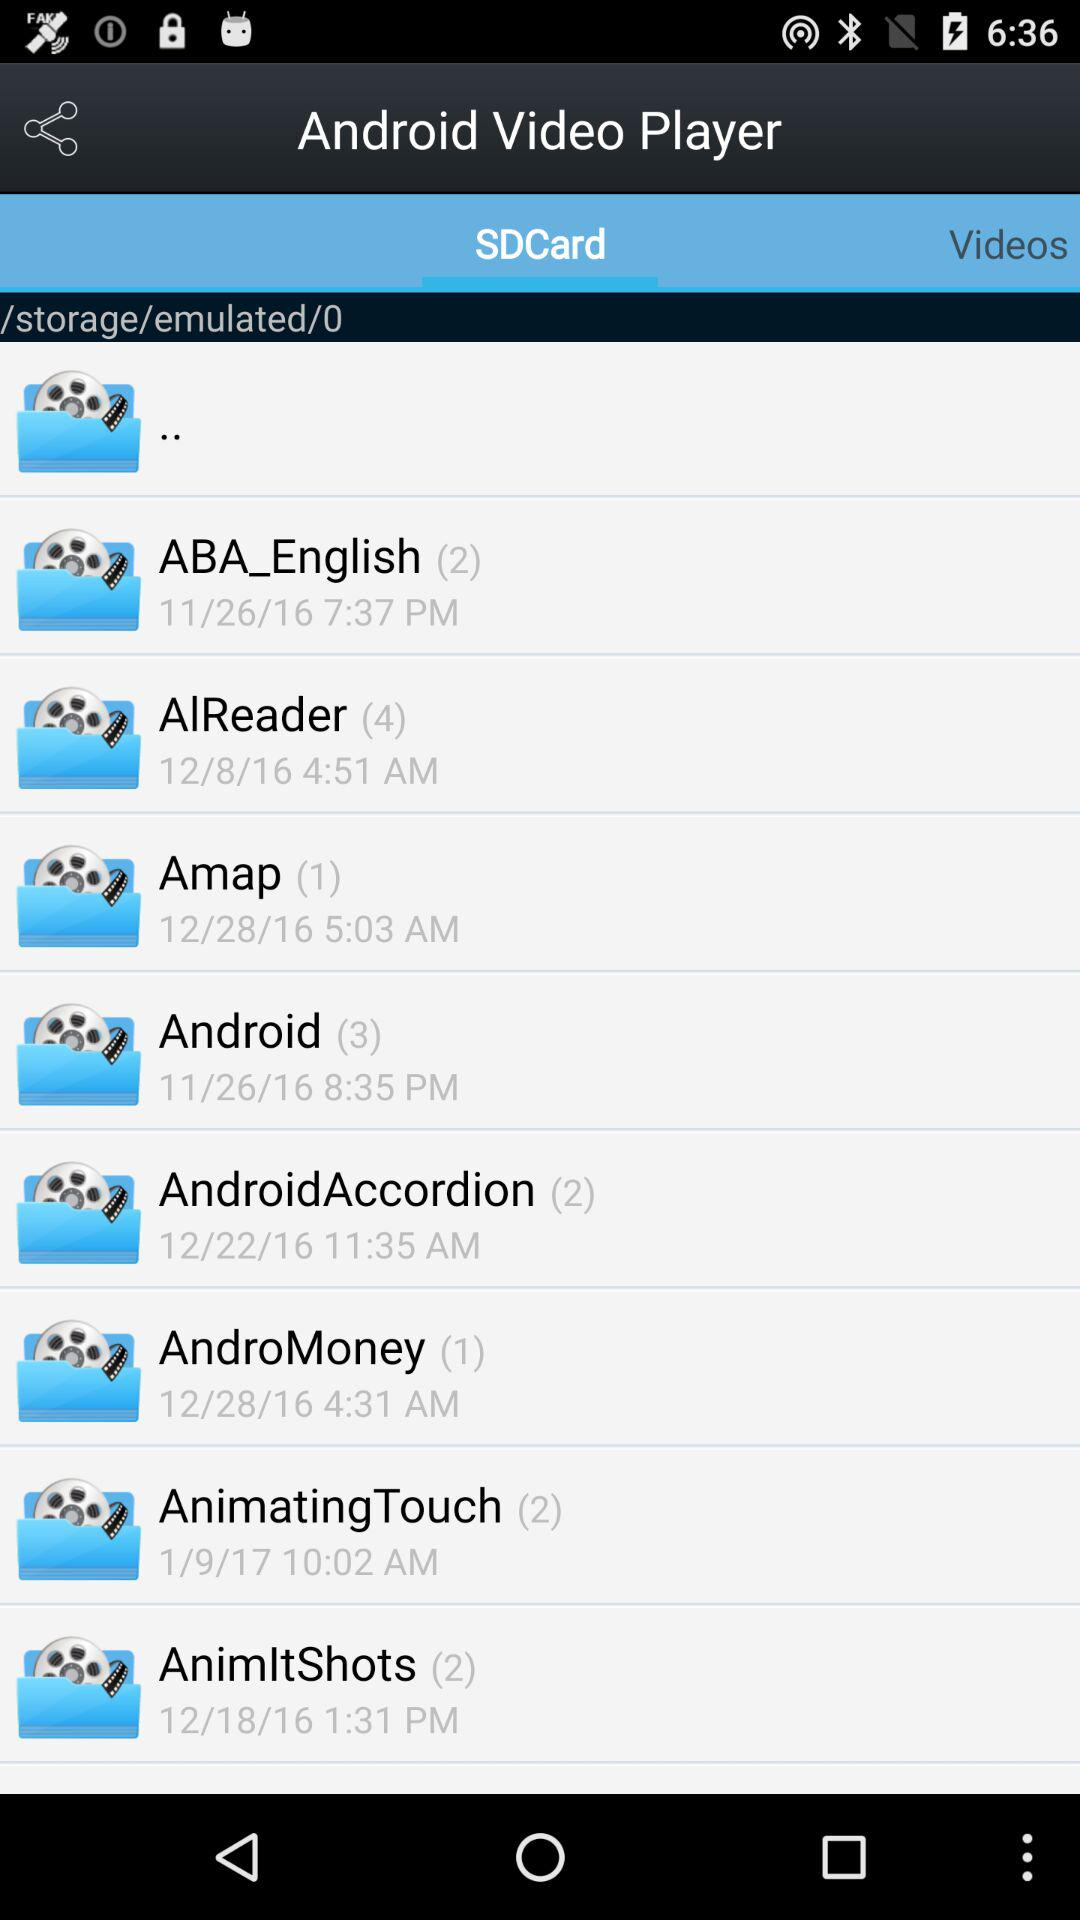On what date was the folder "AndroMoney" created? The folder "AndroMoney" was created on 12/28/16. 